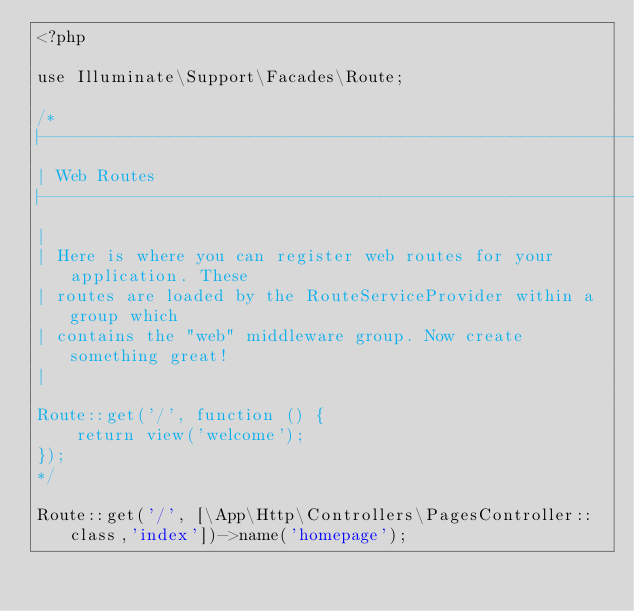Convert code to text. <code><loc_0><loc_0><loc_500><loc_500><_PHP_><?php

use Illuminate\Support\Facades\Route;

/*
|--------------------------------------------------------------------------
| Web Routes
|--------------------------------------------------------------------------
|
| Here is where you can register web routes for your application. These
| routes are loaded by the RouteServiceProvider within a group which
| contains the "web" middleware group. Now create something great!
|

Route::get('/', function () {
    return view('welcome');
});
*/

Route::get('/', [\App\Http\Controllers\PagesController::class,'index'])->name('homepage');</code> 